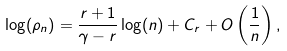Convert formula to latex. <formula><loc_0><loc_0><loc_500><loc_500>\log ( \rho _ { n } ) = \frac { r + 1 } { \gamma - r } \log ( n ) + C _ { r } + O \left ( \frac { 1 } { n } \right ) ,</formula> 